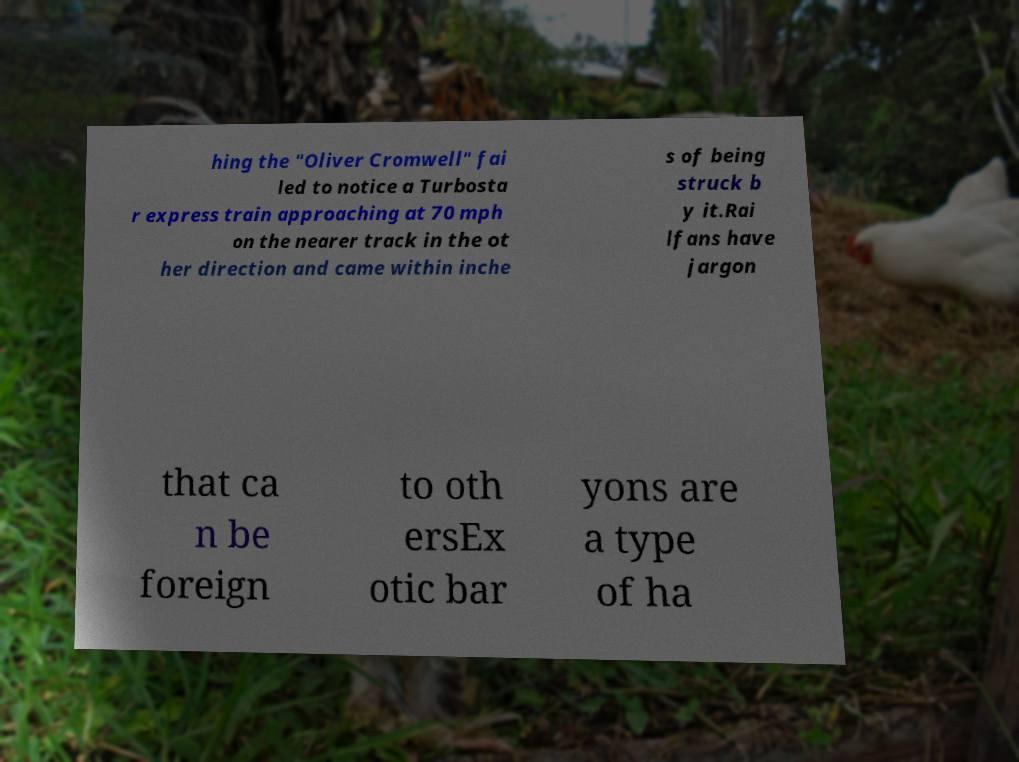Could you assist in decoding the text presented in this image and type it out clearly? hing the "Oliver Cromwell" fai led to notice a Turbosta r express train approaching at 70 mph on the nearer track in the ot her direction and came within inche s of being struck b y it.Rai lfans have jargon that ca n be foreign to oth ersEx otic bar yons are a type of ha 